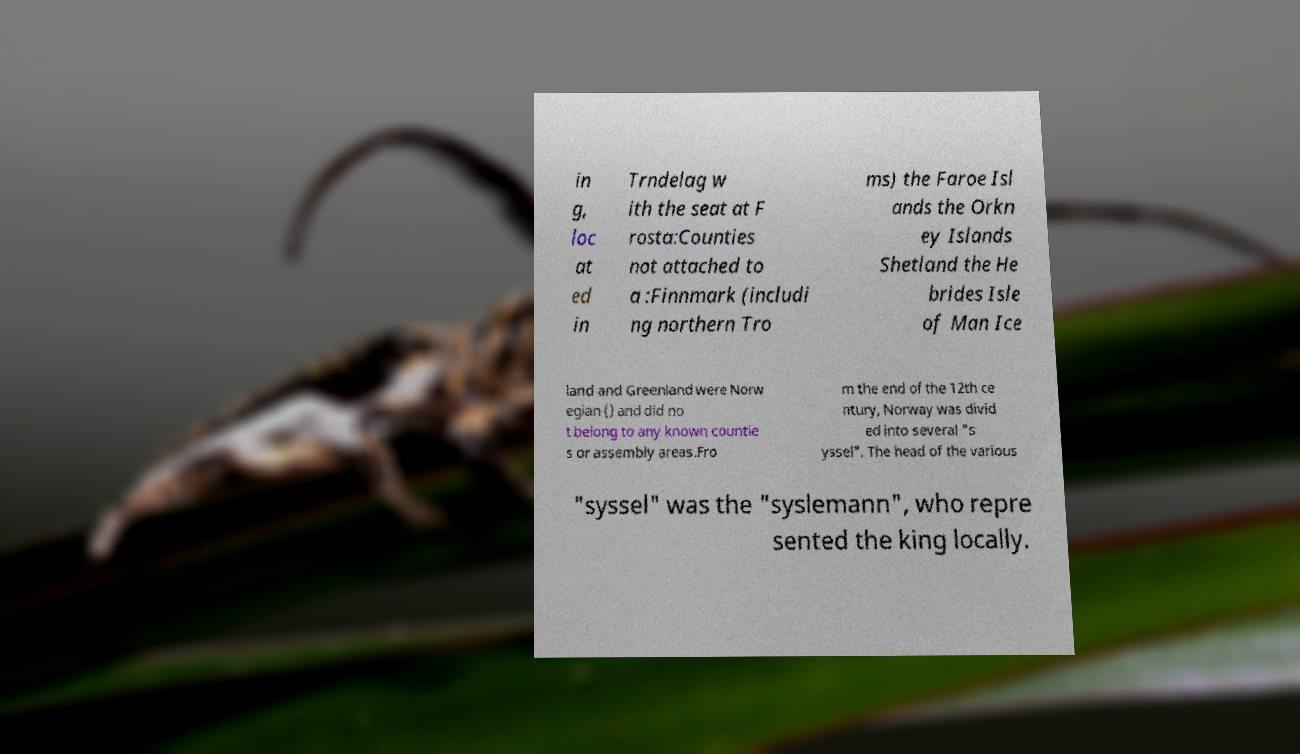For documentation purposes, I need the text within this image transcribed. Could you provide that? in g, loc at ed in Trndelag w ith the seat at F rosta:Counties not attached to a :Finnmark (includi ng northern Tro ms) the Faroe Isl ands the Orkn ey Islands Shetland the He brides Isle of Man Ice land and Greenland were Norw egian () and did no t belong to any known countie s or assembly areas.Fro m the end of the 12th ce ntury, Norway was divid ed into several "s yssel". The head of the various "syssel" was the "syslemann", who repre sented the king locally. 